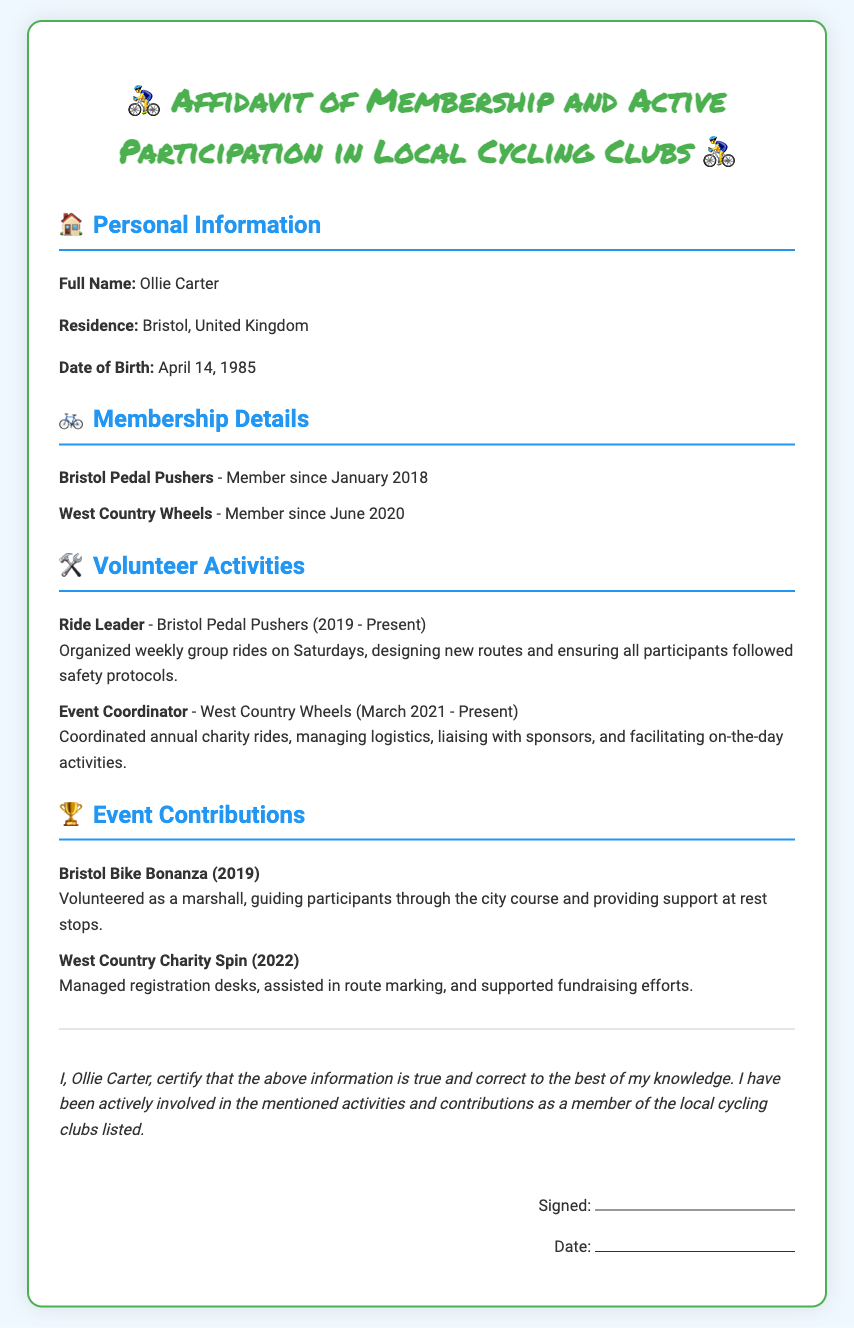What is the full name of the individual? The document states the full name as Ollie Carter.
Answer: Ollie Carter Where does Ollie Carter reside? The residence listed in the document is Bristol, United Kingdom.
Answer: Bristol, United Kingdom When did Ollie become a member of Bristol Pedal Pushers? The membership date for Bristol Pedal Pushers is provided as January 2018.
Answer: January 2018 What role does Ollie Carter have at Bristol Pedal Pushers? The document mentions that Ollie is a Ride Leader at Bristol Pedal Pushers.
Answer: Ride Leader How long has Ollie been an Event Coordinator for West Country Wheels? Ollie has held the title of Event Coordinator since March 2021, which indicates the duration is over two years.
Answer: Over two years What type of event was the Bristol Bike Bonanza? The document specifies that Ollie volunteered as a marshall at this event.
Answer: Marshall What is the purpose of the affidavit? The affidavit serves to certify that the information provided about Ollie’s membership and activities is true and correct.
Answer: Certify truth of information Which charity ride occurred in 2022? The West Country Charity Spin is mentioned as the charity ride that took place in 2022.
Answer: West Country Charity Spin What does Ollie do for the annual charity rides? The role he undertakes is as an Event Coordinator, coordinating logistics and activities.
Answer: Coordinating logistics and activities 